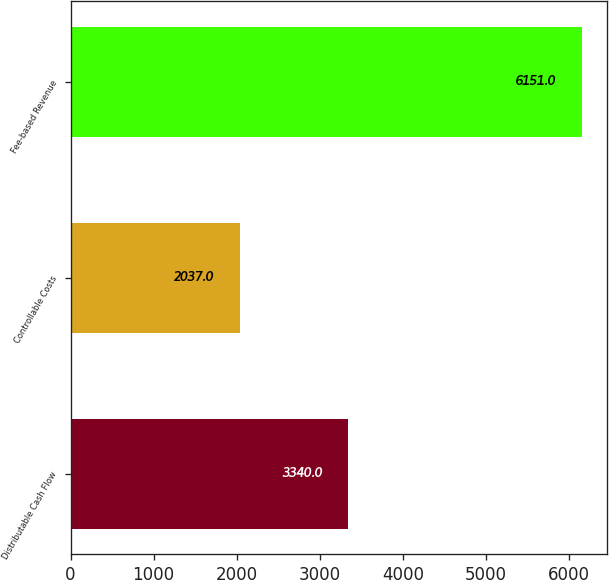Convert chart. <chart><loc_0><loc_0><loc_500><loc_500><bar_chart><fcel>Distributable Cash Flow<fcel>Controllable Costs<fcel>Fee-based Revenue<nl><fcel>3340<fcel>2037<fcel>6151<nl></chart> 